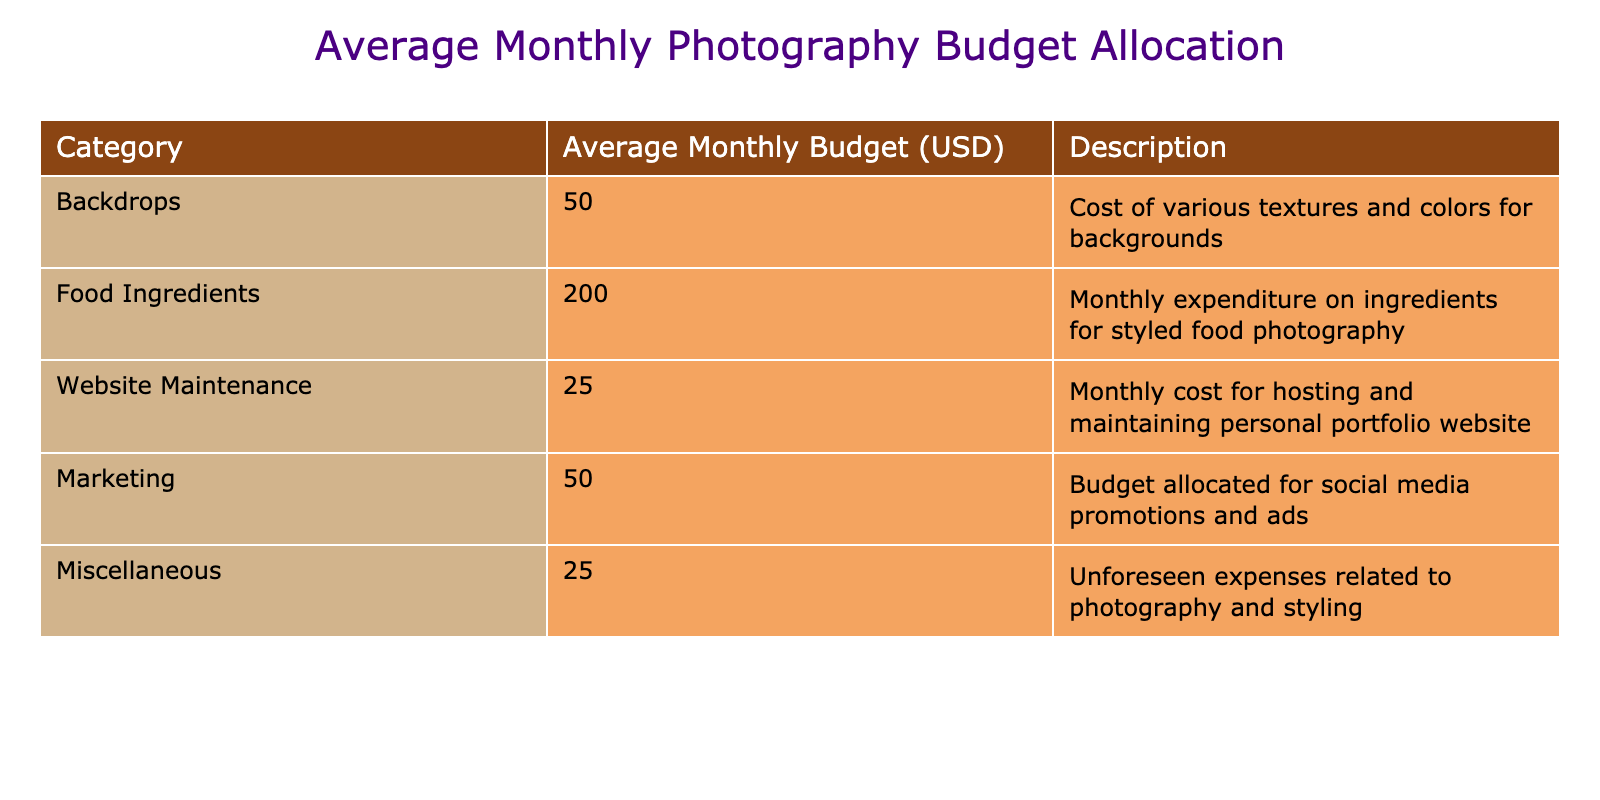What is the average budget allocated for food ingredients? The table clearly lists the average monthly budget for food ingredients as 200 USD. Therefore, this is a direct retrieval question.
Answer: 200 USD How much is spent on marketing compared to website maintenance? The budget for marketing is 50 USD, while for website maintenance, it is 25 USD. The difference is 50 - 25 = 25 USD, indicating that marketing receives 25 USD more than website maintenance.
Answer: Marketing is 25 USD more Is the total budget for backdrops and miscellaneous expenses greater than that for food ingredients? The total for backdrops is 50 USD and miscellaneous expenses is 25 USD. Adding them gives 50 + 25 = 75 USD, which is less than the food ingredients cost of 200 USD. Therefore, the statement is false.
Answer: No What is the total average budget allocation for all categories combined? The total is calculated by summing all monthly budgets: 50 (Backdrops) + 200 (Food Ingredients) + 25 (Website Maintenance) + 50 (Marketing) + 25 (Miscellaneous) = 350 USD.
Answer: 350 USD Is the budget for food ingredients more than double the budget for marketing? The budget for food ingredients is 200 USD and for marketing, it is 50 USD. Double the marketing budget is 50 * 2 = 100 USD. Since 200 USD is greater than 100 USD, the statement is true.
Answer: Yes What percentage of the total budget is allocated for website maintenance? The total budget is 350 USD. The budget for website maintenance is 25 USD. To find the percentage, the formula is (25 / 350) * 100, which is approximately 7.14%.
Answer: Approximately 7.14% If the budget for backdrops is reduced by 10 USD, what will the new total budget be? The new budget for backdrops would be 50 - 10 = 40 USD. Adding this to the other categories, the new total becomes 40 + 200 + 25 + 50 + 25 = 340 USD, which is a reduction of 10 USD from the previous total of 350 USD.
Answer: 340 USD What is the relationship between miscellaneous expenses and the marketing budget, in terms of percentage? Miscellaneous expenses are 25 USD and the marketing budget is 50 USD. To calculate the percentage of miscellaneous expenses in relation to marketing, use (25 / 50) * 100, which equals 50%.
Answer: 50% 